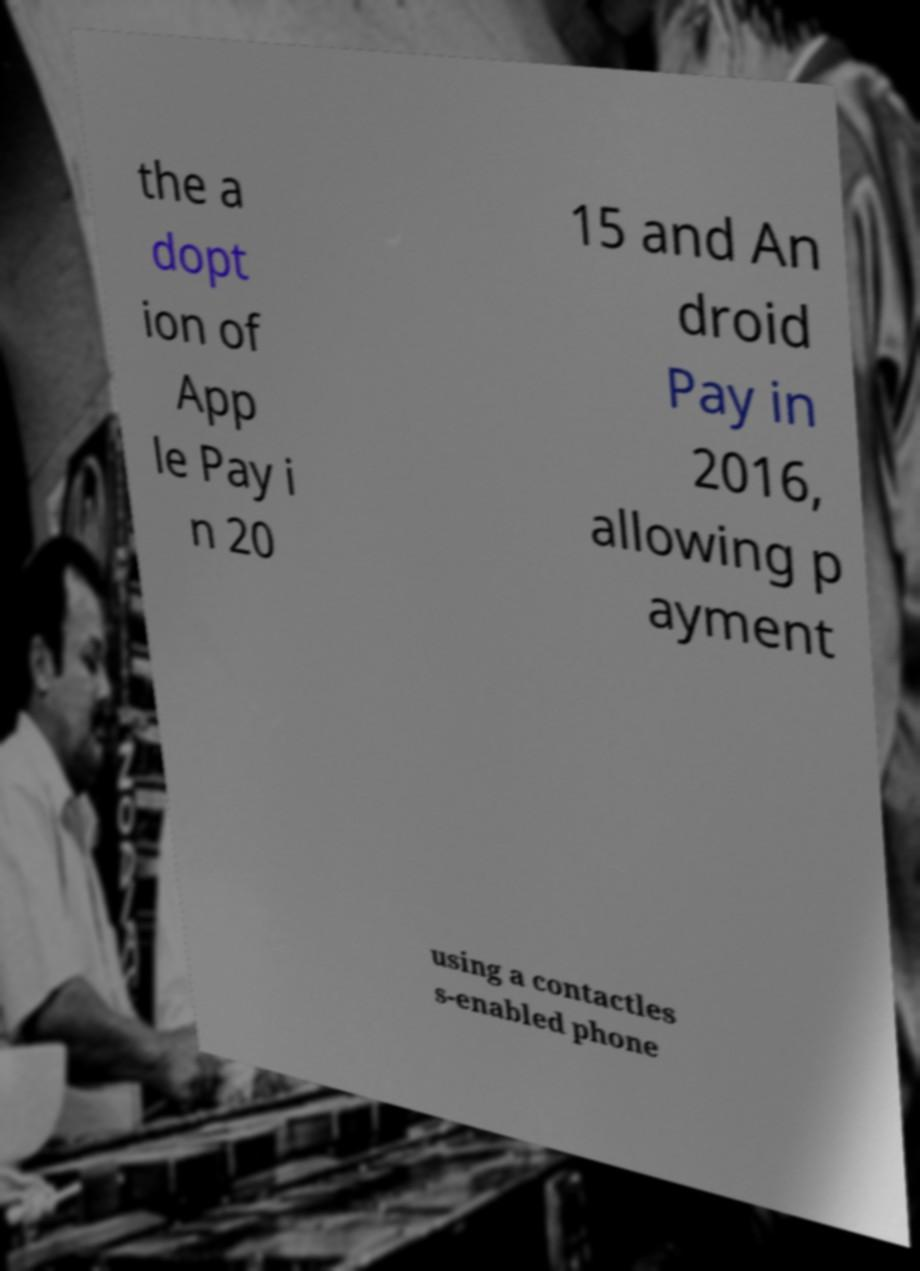Please read and relay the text visible in this image. What does it say? the a dopt ion of App le Pay i n 20 15 and An droid Pay in 2016, allowing p ayment using a contactles s-enabled phone 